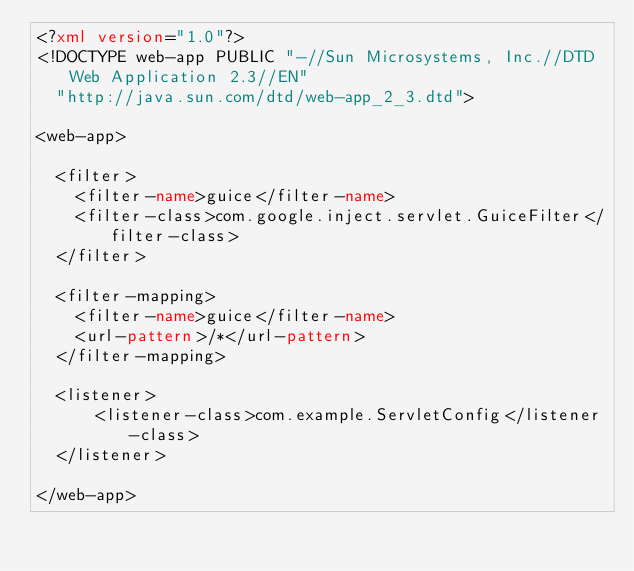Convert code to text. <code><loc_0><loc_0><loc_500><loc_500><_XML_><?xml version="1.0"?>
<!DOCTYPE web-app PUBLIC "-//Sun Microsystems, Inc.//DTD Web Application 2.3//EN"
  "http://java.sun.com/dtd/web-app_2_3.dtd">

<web-app>

  <filter>
    <filter-name>guice</filter-name>
    <filter-class>com.google.inject.servlet.GuiceFilter</filter-class>
  </filter>

  <filter-mapping>
    <filter-name>guice</filter-name>
    <url-pattern>/*</url-pattern>
  </filter-mapping>

  <listener>
      <listener-class>com.example.ServletConfig</listener-class>
  </listener>  

</web-app>
</code> 